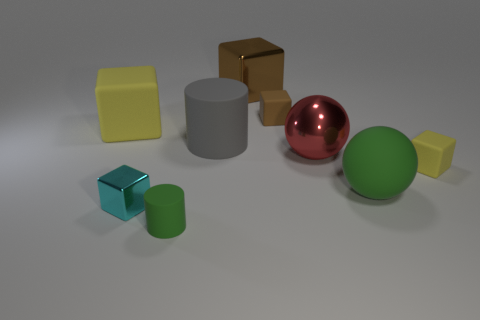Can you compare the reflective properties of the objects? Certainly, the sphere and the cube on the right have highly reflective surfaces, potentially metallic, with the sphere showing a pinkish hue and the cube reflecting gold. The other objects have matte finishes, absorbing more light than reflecting. 